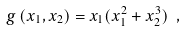<formula> <loc_0><loc_0><loc_500><loc_500>g \left ( x _ { 1 } , x _ { 2 } \right ) = x _ { 1 } ( x _ { 1 } ^ { 2 } + x _ { 2 } ^ { 3 } ) \ ,</formula> 